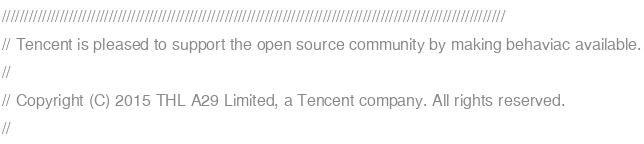Convert code to text. <code><loc_0><loc_0><loc_500><loc_500><_C_>/////////////////////////////////////////////////////////////////////////////////////////////////////////////////
// Tencent is pleased to support the open source community by making behaviac available.
//
// Copyright (C) 2015 THL A29 Limited, a Tencent company. All rights reserved.
//</code> 